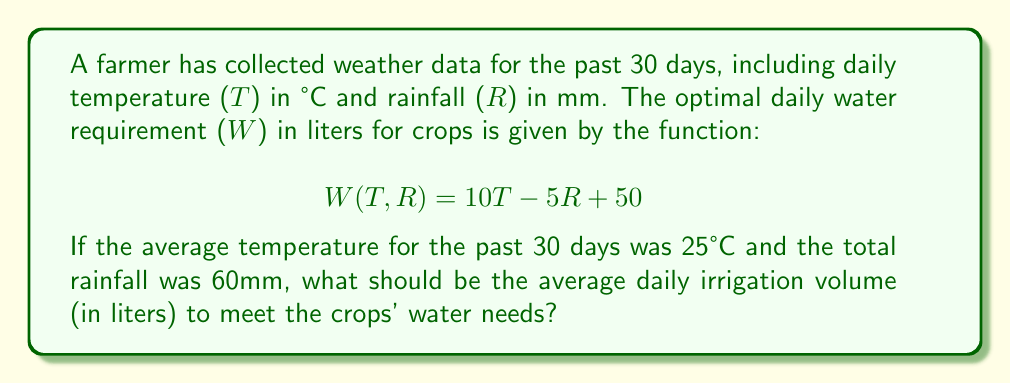Could you help me with this problem? To solve this problem, we'll follow these steps:

1. Understand the given information:
   - Average temperature (T) = 25°C
   - Total rainfall over 30 days = 60mm
   - Water requirement function: $W(T,R) = 10T - 5R + 50$

2. Calculate the average daily rainfall:
   $R_{daily} = \frac{Total\ rainfall}{Number\ of\ days} = \frac{60\ mm}{30\ days} = 2\ mm/day$

3. Plug the average temperature and daily rainfall into the water requirement function:
   $$W(25,2) = 10(25) - 5(2) + 50$$

4. Calculate the result:
   $$W(25,2) = 250 - 10 + 50 = 290\ liters$$

5. The result, 290 liters, represents the average daily water requirement for the crops.

6. Since we want to know the irrigation volume, we need to subtract the average daily rainfall from this requirement:
   $Irrigation\ volume = Water\ requirement - Rainfall$
   $Irrigation\ volume = 290\ liters - (2\ mm \times 1\ liter/mm) = 288\ liters$

Therefore, the average daily irrigation volume should be 288 liters to meet the crops' water needs.
Answer: 288 liters 